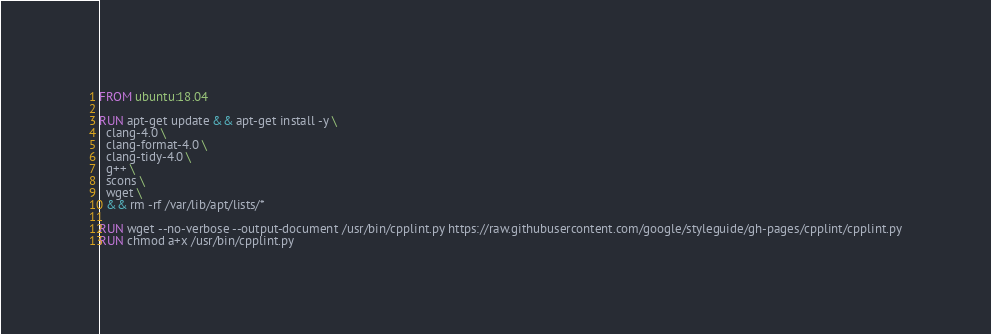Convert code to text. <code><loc_0><loc_0><loc_500><loc_500><_Dockerfile_>FROM ubuntu:18.04

RUN apt-get update && apt-get install -y \
  clang-4.0 \
  clang-format-4.0 \
  clang-tidy-4.0 \
  g++ \
  scons \
  wget \
  && rm -rf /var/lib/apt/lists/*

RUN wget --no-verbose --output-document /usr/bin/cpplint.py https://raw.githubusercontent.com/google/styleguide/gh-pages/cpplint/cpplint.py
RUN chmod a+x /usr/bin/cpplint.py
</code> 